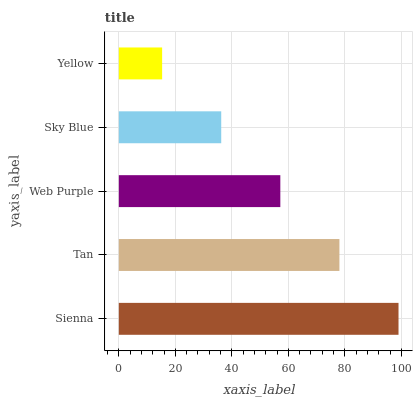Is Yellow the minimum?
Answer yes or no. Yes. Is Sienna the maximum?
Answer yes or no. Yes. Is Tan the minimum?
Answer yes or no. No. Is Tan the maximum?
Answer yes or no. No. Is Sienna greater than Tan?
Answer yes or no. Yes. Is Tan less than Sienna?
Answer yes or no. Yes. Is Tan greater than Sienna?
Answer yes or no. No. Is Sienna less than Tan?
Answer yes or no. No. Is Web Purple the high median?
Answer yes or no. Yes. Is Web Purple the low median?
Answer yes or no. Yes. Is Yellow the high median?
Answer yes or no. No. Is Sky Blue the low median?
Answer yes or no. No. 